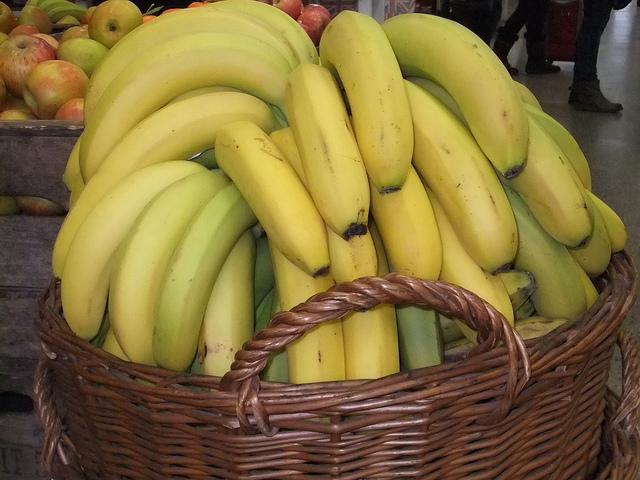What pome fruits are shown here? Please explain your reasoning. apples. A basket if filled with bunches of long yellow fruits. 